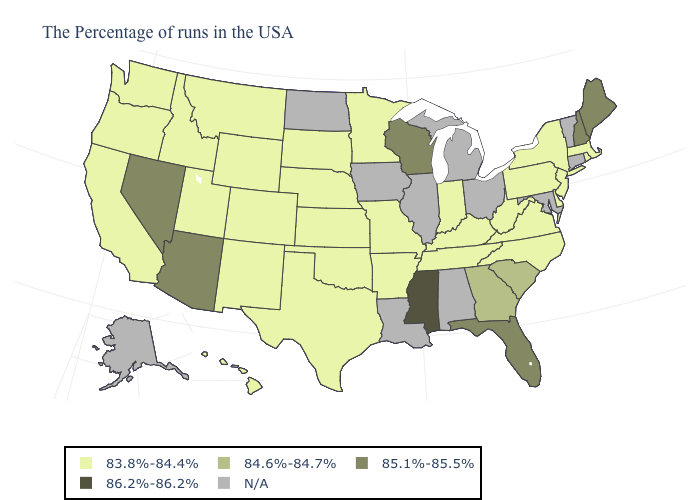Does the first symbol in the legend represent the smallest category?
Be succinct. Yes. What is the value of Massachusetts?
Answer briefly. 83.8%-84.4%. What is the value of Iowa?
Be succinct. N/A. Which states hav the highest value in the Northeast?
Give a very brief answer. Maine, New Hampshire. Name the states that have a value in the range 84.6%-84.7%?
Answer briefly. South Carolina, Georgia. Name the states that have a value in the range 84.6%-84.7%?
Keep it brief. South Carolina, Georgia. How many symbols are there in the legend?
Be succinct. 5. Does the map have missing data?
Short answer required. Yes. Does the first symbol in the legend represent the smallest category?
Short answer required. Yes. Does New Jersey have the highest value in the Northeast?
Concise answer only. No. Does the map have missing data?
Concise answer only. Yes. What is the value of Hawaii?
Answer briefly. 83.8%-84.4%. Which states have the lowest value in the USA?
Short answer required. Massachusetts, Rhode Island, New York, New Jersey, Delaware, Pennsylvania, Virginia, North Carolina, West Virginia, Kentucky, Indiana, Tennessee, Missouri, Arkansas, Minnesota, Kansas, Nebraska, Oklahoma, Texas, South Dakota, Wyoming, Colorado, New Mexico, Utah, Montana, Idaho, California, Washington, Oregon, Hawaii. Name the states that have a value in the range 86.2%-86.2%?
Keep it brief. Mississippi. 